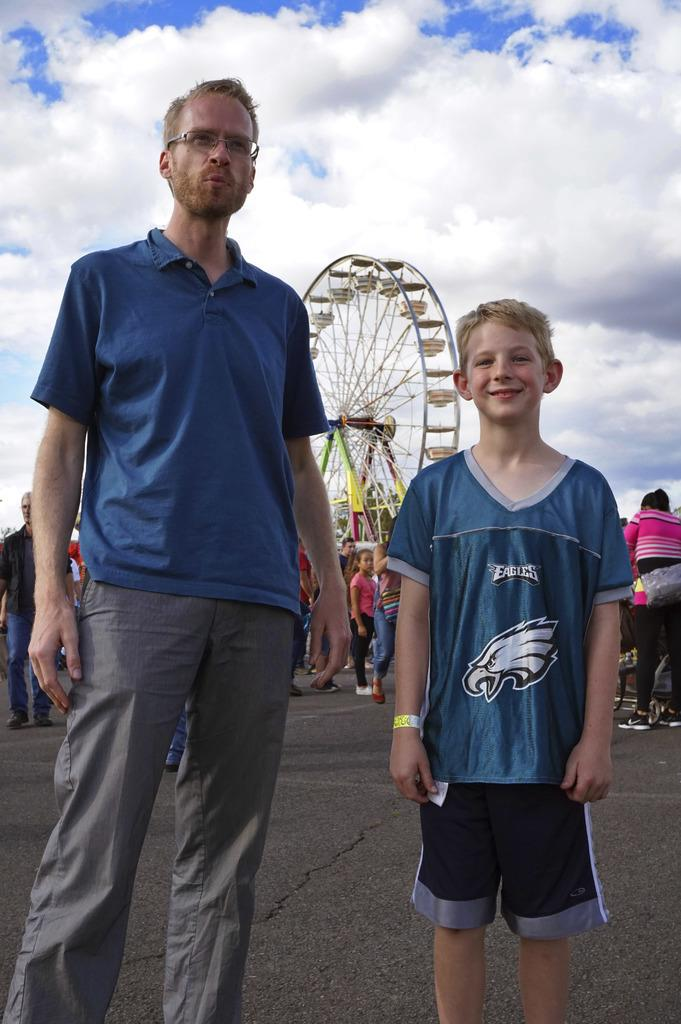Who or what can be seen in the image? There are people in the image. What are the people standing in front of? The people are standing in front of a giant wheel. What can be seen in the distance behind the people and the giant wheel? There is a sky visible in the background of the image. What riddle is being solved by the people in the image? There is no riddle being solved by the people in the image. 